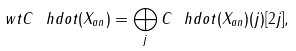Convert formula to latex. <formula><loc_0><loc_0><loc_500><loc_500>\ w t { C } ^ { \ } h d o t ( X _ { a n } ) = \bigoplus _ { j } C ^ { \ } h d o t ( X _ { a n } ) ( j ) [ 2 j ] ,</formula> 